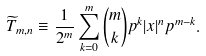<formula> <loc_0><loc_0><loc_500><loc_500>\widetilde { T } _ { m , n } \equiv \frac { 1 } { 2 ^ { m } } \sum _ { k = 0 } ^ { m } \binom { m } { k } p ^ { k } | x | ^ { n } p ^ { m - k } .</formula> 